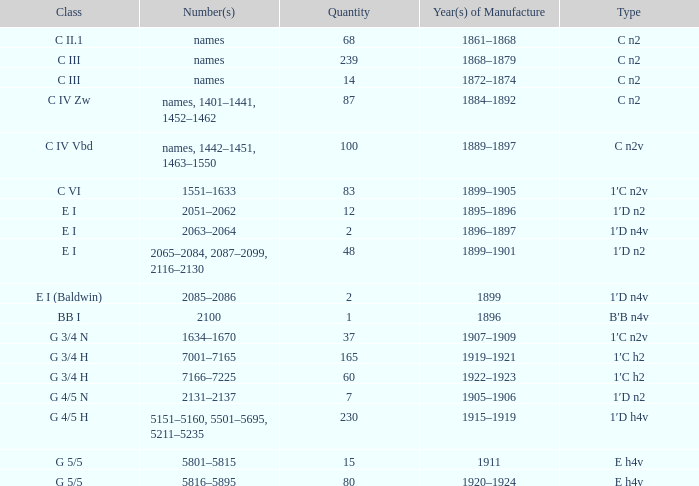Which class has a 1899 fabrication year? E I (Baldwin). 